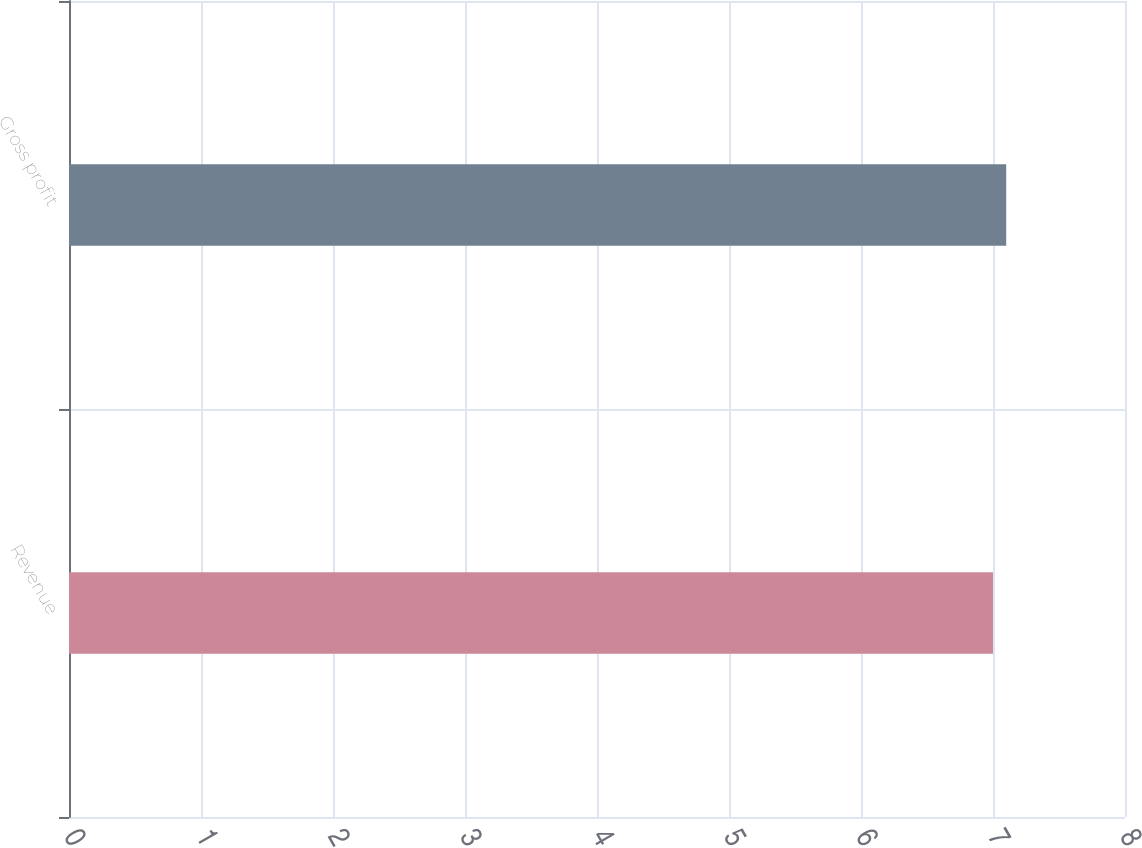Convert chart. <chart><loc_0><loc_0><loc_500><loc_500><bar_chart><fcel>Revenue<fcel>Gross profit<nl><fcel>7<fcel>7.1<nl></chart> 